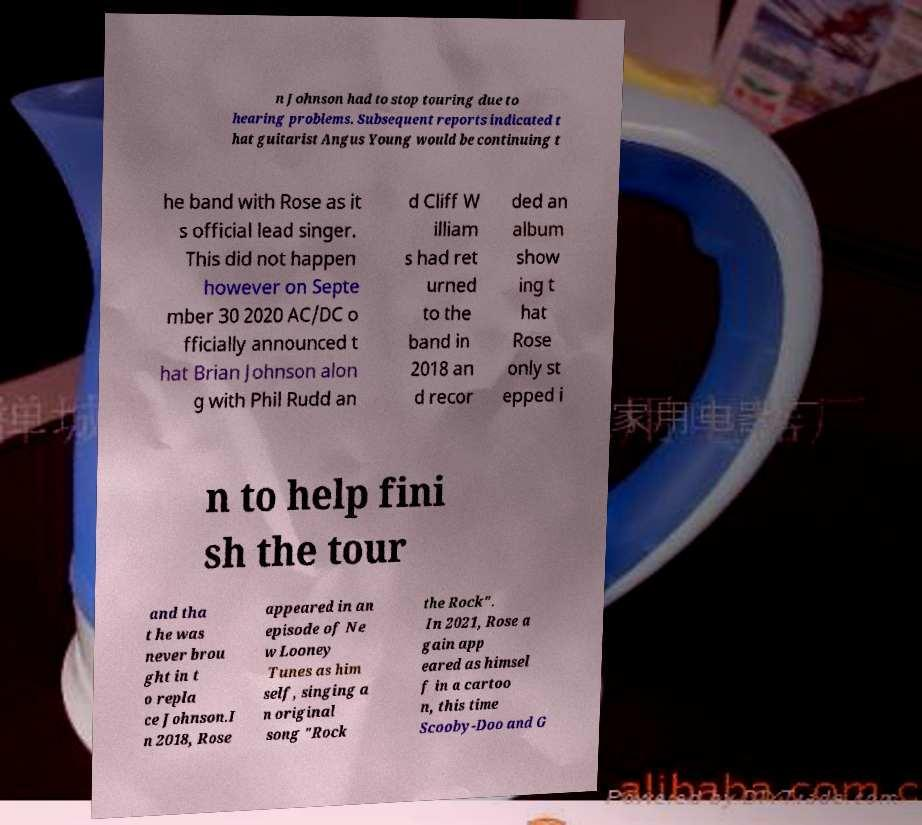Please read and relay the text visible in this image. What does it say? n Johnson had to stop touring due to hearing problems. Subsequent reports indicated t hat guitarist Angus Young would be continuing t he band with Rose as it s official lead singer. This did not happen however on Septe mber 30 2020 AC/DC o fficially announced t hat Brian Johnson alon g with Phil Rudd an d Cliff W illiam s had ret urned to the band in 2018 an d recor ded an album show ing t hat Rose only st epped i n to help fini sh the tour and tha t he was never brou ght in t o repla ce Johnson.I n 2018, Rose appeared in an episode of Ne w Looney Tunes as him self, singing a n original song "Rock the Rock". In 2021, Rose a gain app eared as himsel f in a cartoo n, this time Scooby-Doo and G 